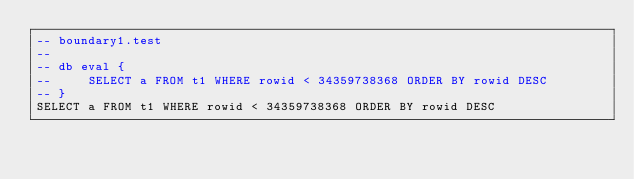<code> <loc_0><loc_0><loc_500><loc_500><_SQL_>-- boundary1.test
-- 
-- db eval {
--     SELECT a FROM t1 WHERE rowid < 34359738368 ORDER BY rowid DESC
-- }
SELECT a FROM t1 WHERE rowid < 34359738368 ORDER BY rowid DESC</code> 